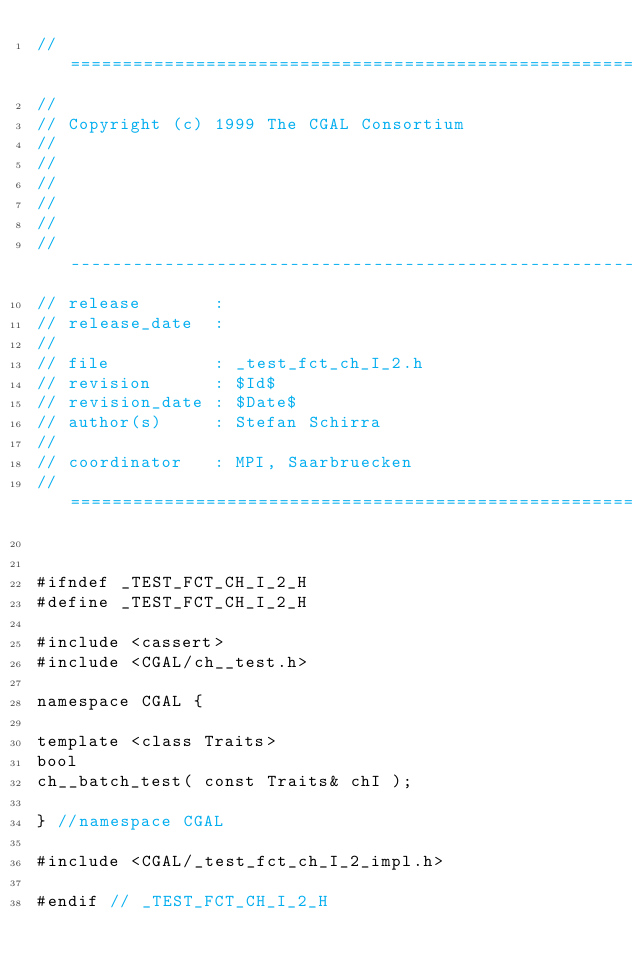Convert code to text. <code><loc_0><loc_0><loc_500><loc_500><_C_>// ============================================================================
//
// Copyright (c) 1999 The CGAL Consortium
//
//
//
//
//
// ----------------------------------------------------------------------------
// release       :
// release_date  :
//
// file          : _test_fct_ch_I_2.h
// revision      : $Id$
// revision_date : $Date$
// author(s)     : Stefan Schirra
//
// coordinator   : MPI, Saarbruecken
// ============================================================================


#ifndef _TEST_FCT_CH_I_2_H
#define _TEST_FCT_CH_I_2_H

#include <cassert>
#include <CGAL/ch__test.h>

namespace CGAL {

template <class Traits>
bool
ch__batch_test( const Traits& chI );

} //namespace CGAL

#include <CGAL/_test_fct_ch_I_2_impl.h>

#endif // _TEST_FCT_CH_I_2_H
</code> 